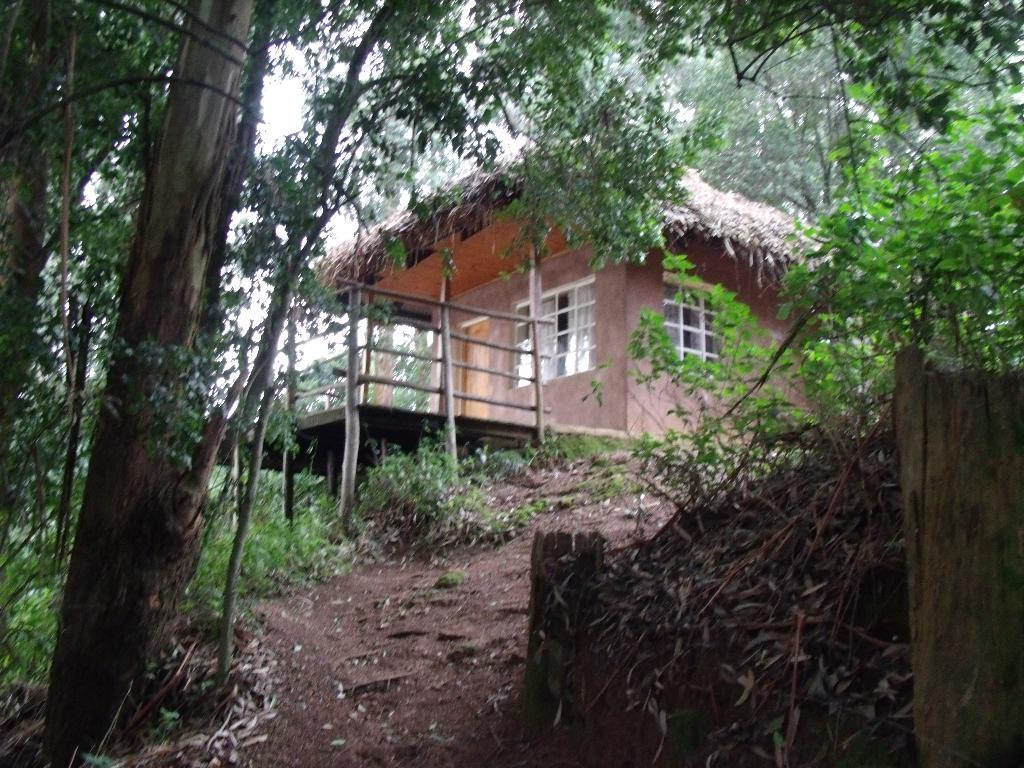What type of vegetation can be seen in the image? There are trees in the image. What type of structure is present in the image? There is a house in the image. What architectural feature can be seen in the image? There are windows in the image. What type of barrier is visible in the image? There is fencing in the image. What is the color of the sky in the image? The sky is white in color. Can you tell me how many brothers are depicted in the image? There are no brothers present in the image. What type of chain can be seen connecting the trees in the image? There is no chain connecting the trees in the image; only the trees themselves are visible. How does the earthquake affect the house in the image? There is no earthquake present in the image; the house appears to be standing upright. 